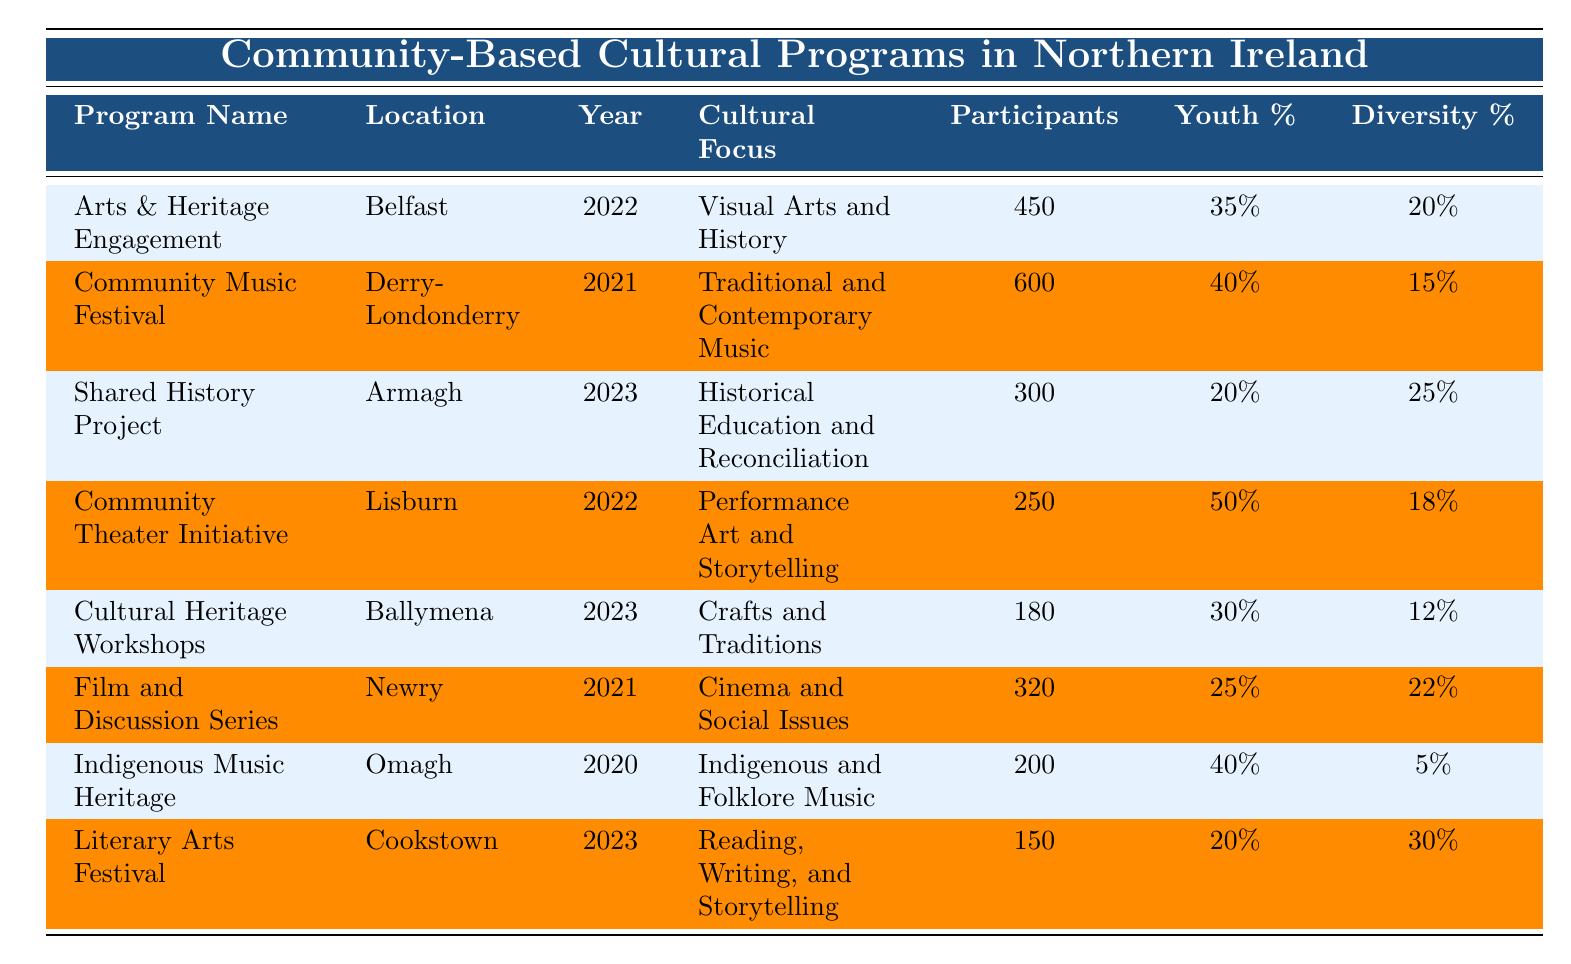What is the total number of participants in all programs from 2021? To find the total number of participants in 2021, I will sum the participants of the programs that occurred that year. The programs are Community Music Festival (600), Film and Discussion Series (320). So, total participants = 600 + 320 = 920.
Answer: 920 Which program had the highest percentage of youth participants? By comparing the youth percentages across all programs, I see that the Community Theater Initiative has the highest youth percentage at 50%.
Answer: Community Theater Initiative Is the diversity percentage of the Shared History Project greater than that of the Cultural Heritage Workshops? The diversity percentage for Shared History Project is 25%, while for Cultural Heritage Workshops it is 12%. Since 25 is greater than 12, the statement is true.
Answer: Yes What is the average number of participants in programs held in 2023? The programs in 2023 are Shared History Project (300), Cultural Heritage Workshops (180), and Literary Arts Festival (150). I calculate the average by summing the participants (300 + 180 + 150 = 630) and dividing by the number of programs (630 / 3 = 210).
Answer: 210 Was there a program in 2020 with fewer than 250 participants? The only program in 2020 is Indigenous Music Heritage, which had 200 participants. Since 200 is less than 250, the answer is true.
Answer: Yes How many programs had a focus on historical themes, and what are their names? The programs with a focus on historical themes are the Shared History Project and the Arts & Heritage Engagement. Therefore, there are two such programs.
Answer: 2 (Shared History Project, Arts & Heritage Engagement) What is the difference in the number of participants between the Community Music Festival and the Literary Arts Festival? The Community Music Festival had 600 participants and the Literary Arts Festival had 150 participants. The difference is calculated as 600 - 150 = 450.
Answer: 450 Which location hosted the most cultural programs listed in the table? By examining the programs, it's clear that Belfast (Arts & Heritage Engagement) and Derry-Londonderry (Community Music Festival) are the only locations hosting one program each. Hence, no location hosted more than one program based on the given data.
Answer: None What percentage of participants in the Film and Discussion Series were adults? In the Film and Discussion Series, adults made up 65% of the total participants (320).
Answer: 65% 